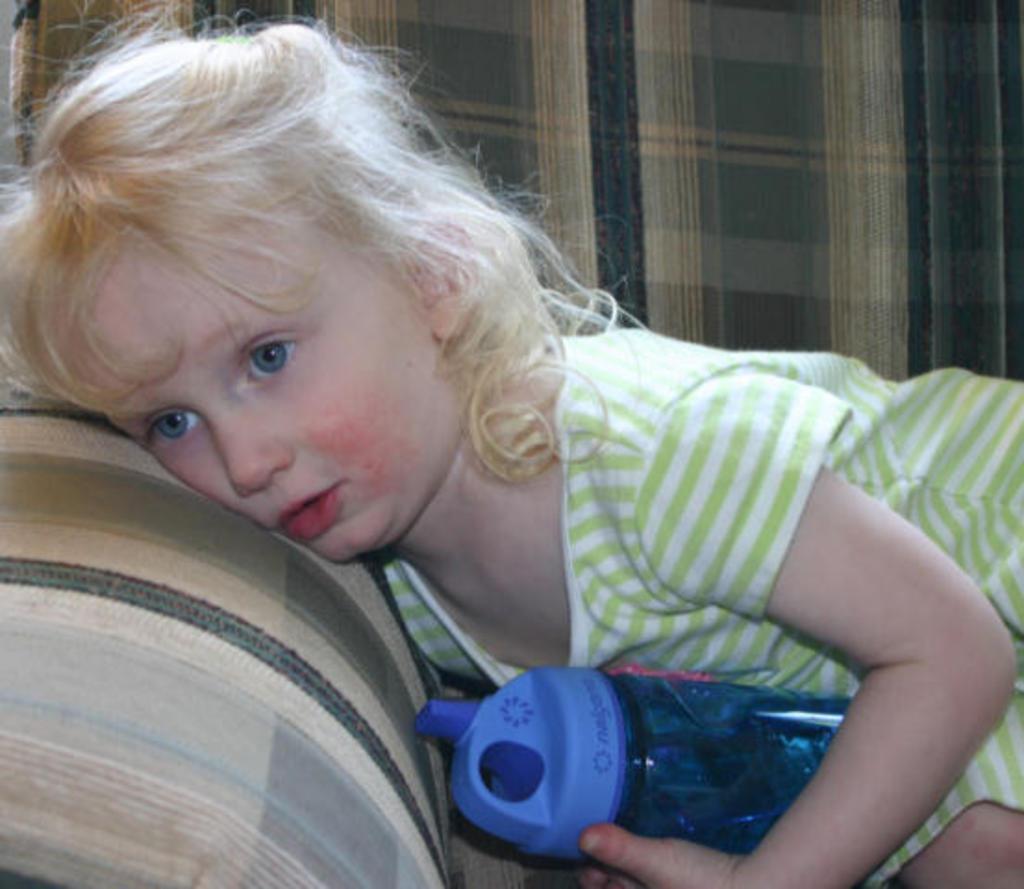Can you describe this image briefly? In this image i can see a girl holding a bottle laying on a couch. 